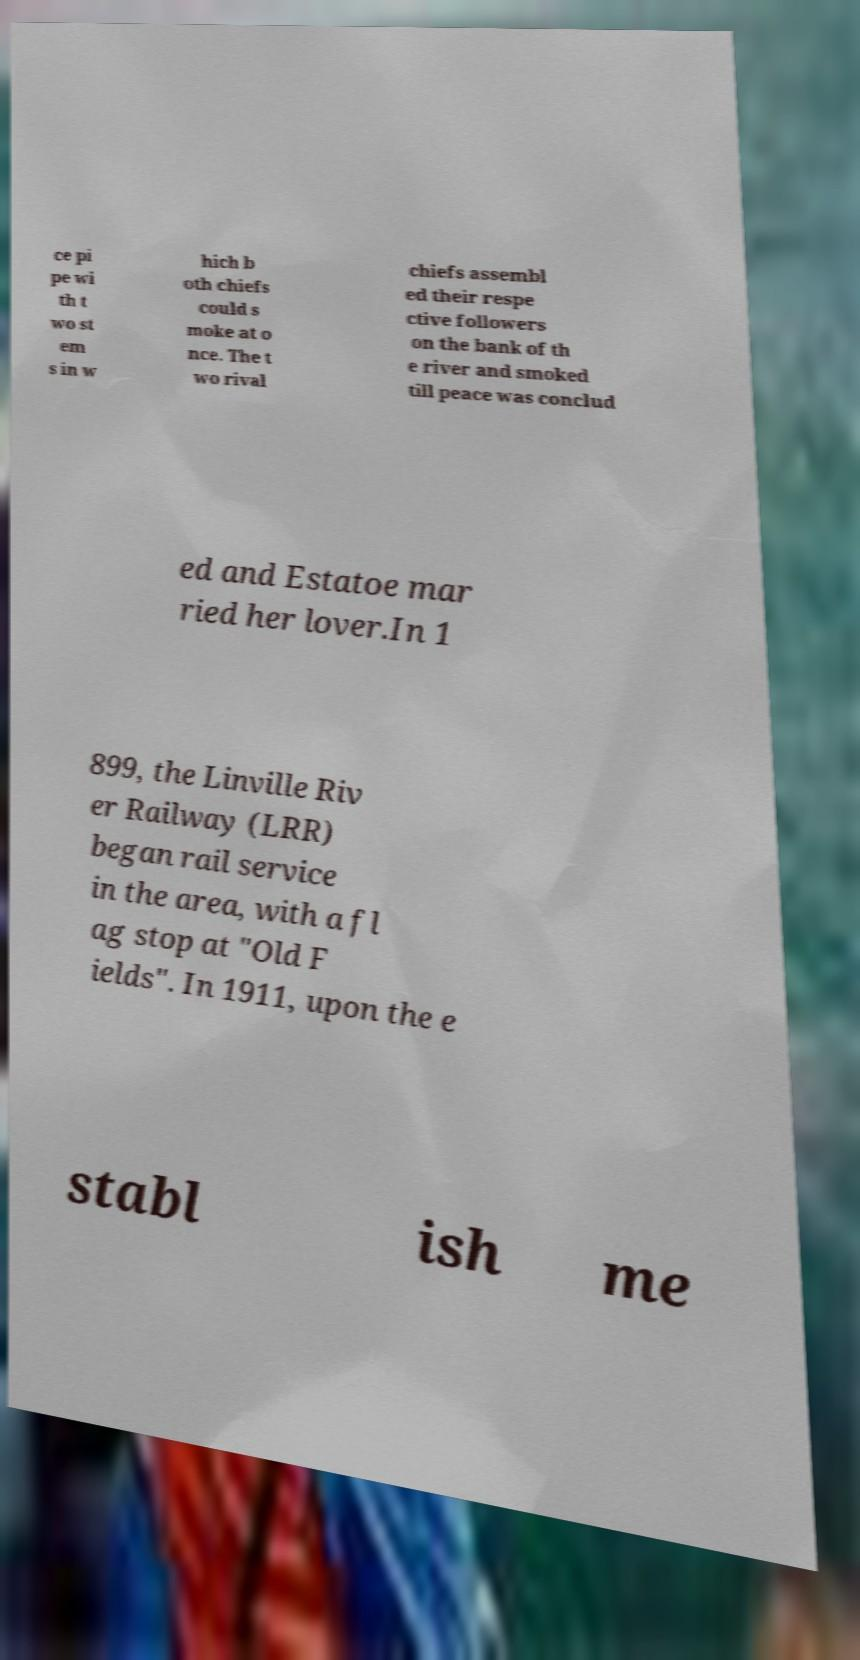Could you extract and type out the text from this image? ce pi pe wi th t wo st em s in w hich b oth chiefs could s moke at o nce. The t wo rival chiefs assembl ed their respe ctive followers on the bank of th e river and smoked till peace was conclud ed and Estatoe mar ried her lover.In 1 899, the Linville Riv er Railway (LRR) began rail service in the area, with a fl ag stop at "Old F ields". In 1911, upon the e stabl ish me 